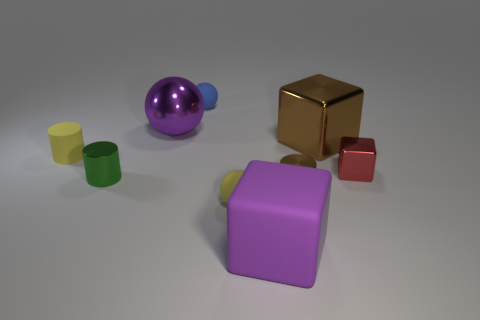What material is the big cube that is behind the tiny brown cylinder?
Offer a very short reply. Metal. There is a thing that is the same color as the big ball; what size is it?
Offer a very short reply. Large. What number of things are either things that are on the left side of the large brown cube or small red blocks?
Your answer should be compact. 8. Are there the same number of metallic cubes that are to the left of the green metal cylinder and tiny gray shiny cylinders?
Your answer should be very brief. Yes. Do the red shiny object and the blue ball have the same size?
Give a very brief answer. Yes. What is the color of the metallic block that is the same size as the yellow matte cylinder?
Keep it short and to the point. Red. There is a yellow sphere; is its size the same as the metal cube that is behind the yellow cylinder?
Offer a terse response. No. How many tiny rubber objects are the same color as the tiny matte cylinder?
Make the answer very short. 1. What number of things are large red blocks or shiny cylinders that are on the right side of the yellow ball?
Ensure brevity in your answer.  1. Do the yellow rubber thing that is on the left side of the purple sphere and the yellow object that is in front of the small red thing have the same size?
Your answer should be compact. Yes. 